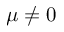Convert formula to latex. <formula><loc_0><loc_0><loc_500><loc_500>\mu \ne 0</formula> 